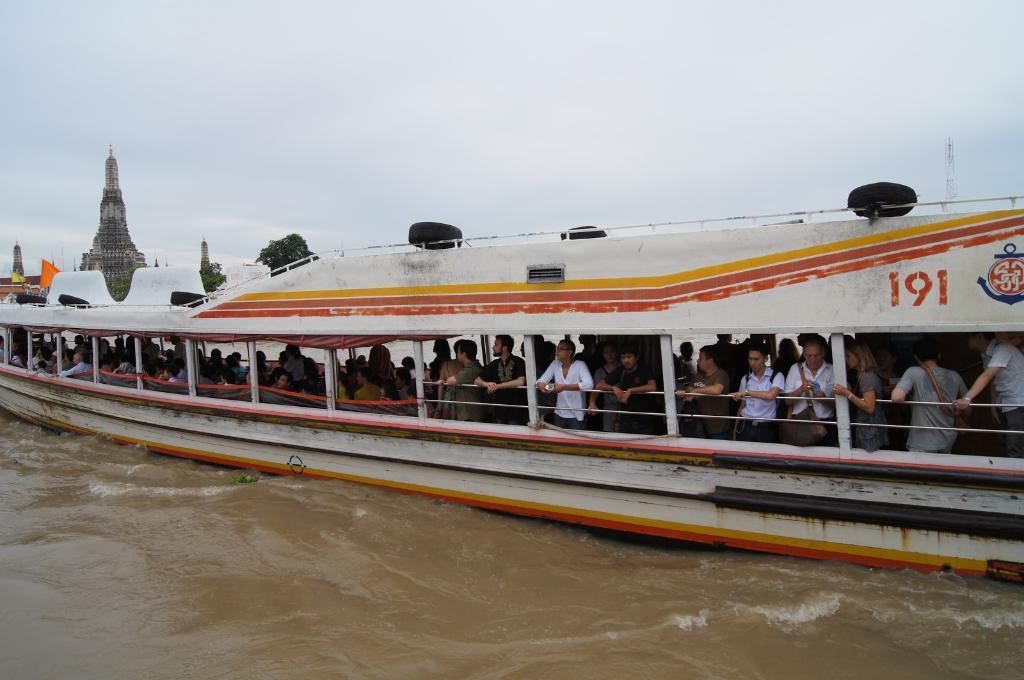In one or two sentences, can you explain what this image depicts? In this image, we can see people in the boat and in the background, there are trees and we can see a building and a flag and there is a tower and some tires on the boat. At the top, there is sky and at the bottom, there is water. 